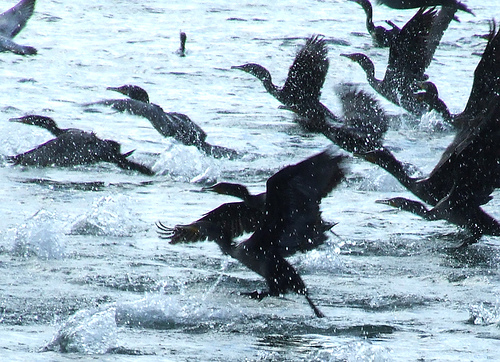What emotions might the birds be experiencing in this scene? The birds might be experiencing a range of emotions, from the exhilaration of flight to the intense focus required for hunting. The splashes and frantic movements suggest a sense of urgency, possibly driven by the need to escape predators or catch prey. The scene is dynamic, hinting at alertness and high energy as they engage in their survival activities. If these birds were characters in a story, what might be happening in this scene? In a story, this scene could depict a critical moment where the birds are either escaping from a predator or embarking on a migratory journey. The chaotic flapping and splashing suggest a sudden disturbance, perhaps a call to migrate as winter approaches, or the urgent need to escape a threat. The protagonist, a particularly agile bird, might be leading the charge, guiding its flock to safety amidst the turmoil. The splashes of water could symbolize the trials and tribulations they must overcome to reach their destination. Can you create a poem inspired by this image? Upon the mirrored pond they dance,
In a ballet of chance and circumstance,
Wings flap, droplets fly,
A flurry under the open sky.

Dark silhouettes in liquid light,
Against the shimmer they take flight,
Urgent cries, the water breaks,
In their wake, the silence shakes.

Each bird's path a tale untold,
In this dance of young and old,
A fleeting moment, wild and free,
Reflected in the restless sea. Envision a future where these birds have evolved. What new traits might they have? In a distant future, these birds could evolve to develop traits perfectly suited to their aquatic environment. They might have webbed feet that function more efficiently for swimming, akin to ducks, combined with strong, streamlined wings for quick, agile flight. Their plumage might become more water-resistant, allowing them to stay dry and maintain aerodynamic efficiency. Enhanced vision could help them see underwater better, aiding in predator detection and hunting. Their calls may evolve into more sophisticated communication signals, enabling better coordination during complex maneuvers in their large flocks. 